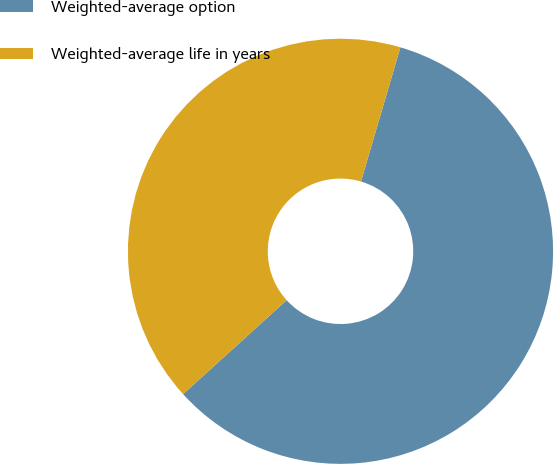<chart> <loc_0><loc_0><loc_500><loc_500><pie_chart><fcel>Weighted-average option<fcel>Weighted-average life in years<nl><fcel>58.73%<fcel>41.27%<nl></chart> 